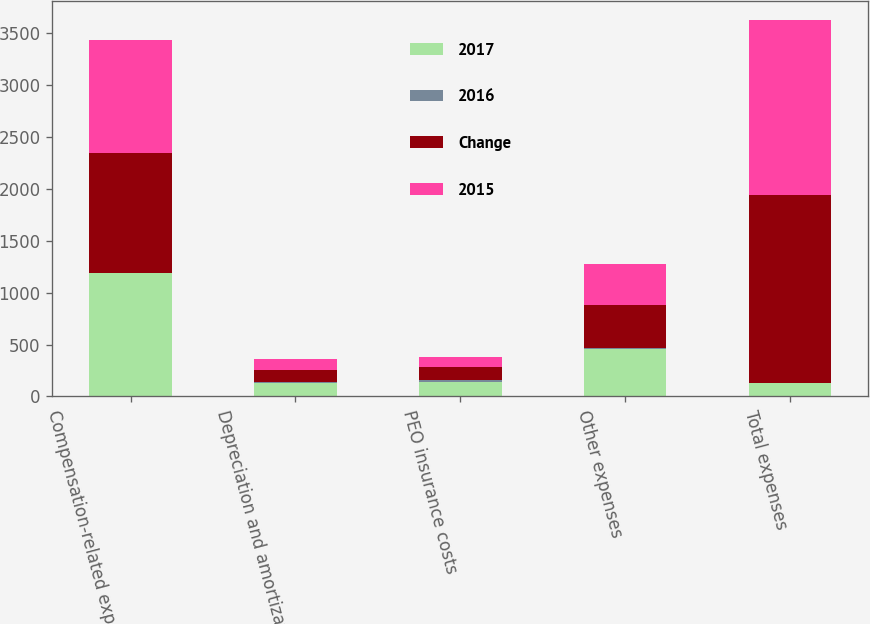Convert chart. <chart><loc_0><loc_0><loc_500><loc_500><stacked_bar_chart><ecel><fcel>Compensation-related expenses<fcel>Depreciation and amortization<fcel>PEO insurance costs<fcel>Other expenses<fcel>Total expenses<nl><fcel>2017<fcel>1188.5<fcel>126.9<fcel>142.2<fcel>454.1<fcel>126.9<nl><fcel>2016<fcel>4<fcel>10<fcel>17<fcel>8<fcel>6<nl><fcel>Change<fcel>1148.2<fcel>115.1<fcel>122<fcel>420<fcel>1805.3<nl><fcel>2015<fcel>1087.1<fcel>106.6<fcel>96.2<fcel>396.1<fcel>1686<nl></chart> 